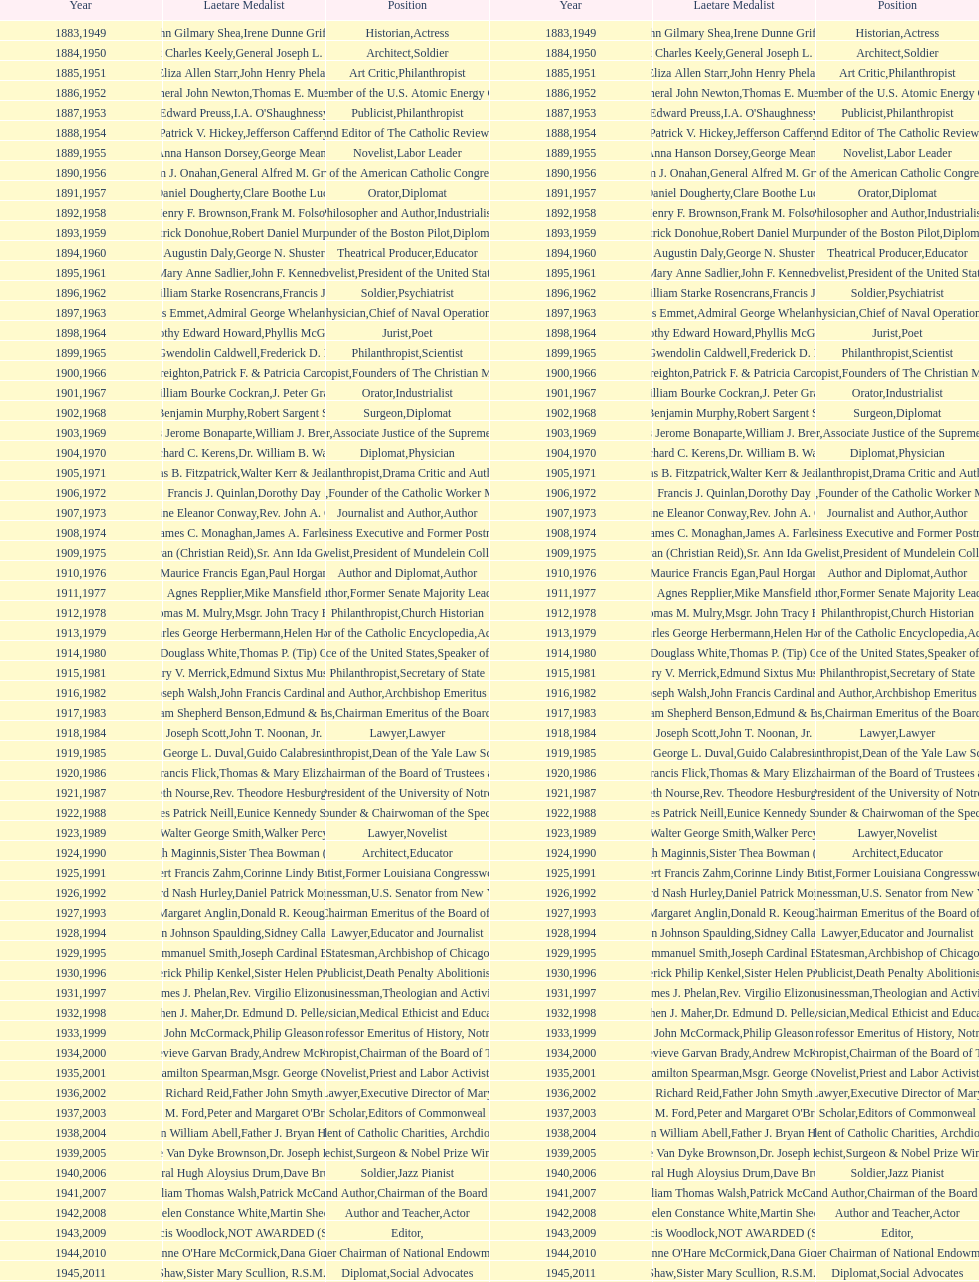Among laetare medalists, how many were involved in philanthropy? 2. 